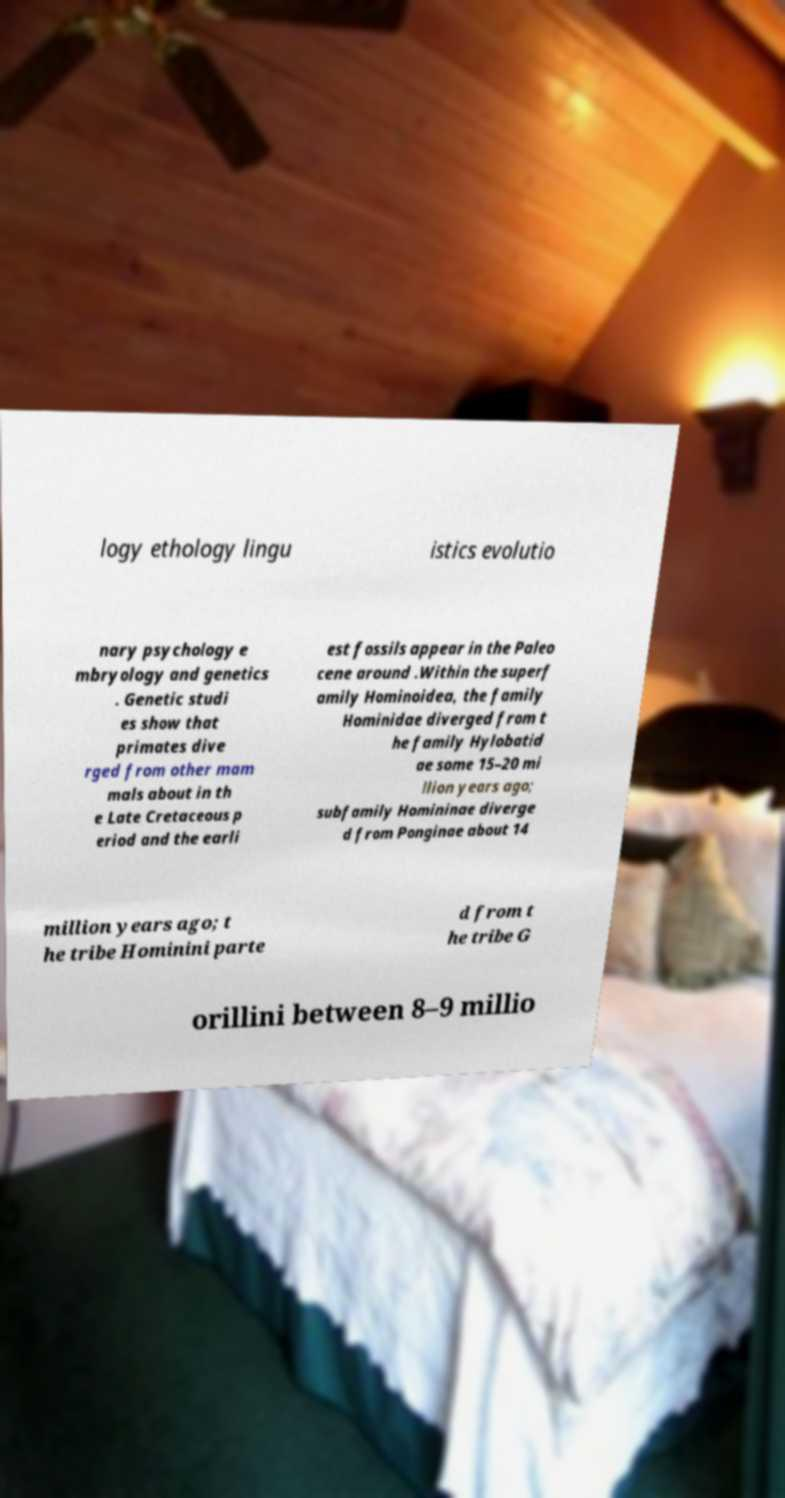What messages or text are displayed in this image? I need them in a readable, typed format. logy ethology lingu istics evolutio nary psychology e mbryology and genetics . Genetic studi es show that primates dive rged from other mam mals about in th e Late Cretaceous p eriod and the earli est fossils appear in the Paleo cene around .Within the superf amily Hominoidea, the family Hominidae diverged from t he family Hylobatid ae some 15–20 mi llion years ago; subfamily Homininae diverge d from Ponginae about 14 million years ago; t he tribe Hominini parte d from t he tribe G orillini between 8–9 millio 